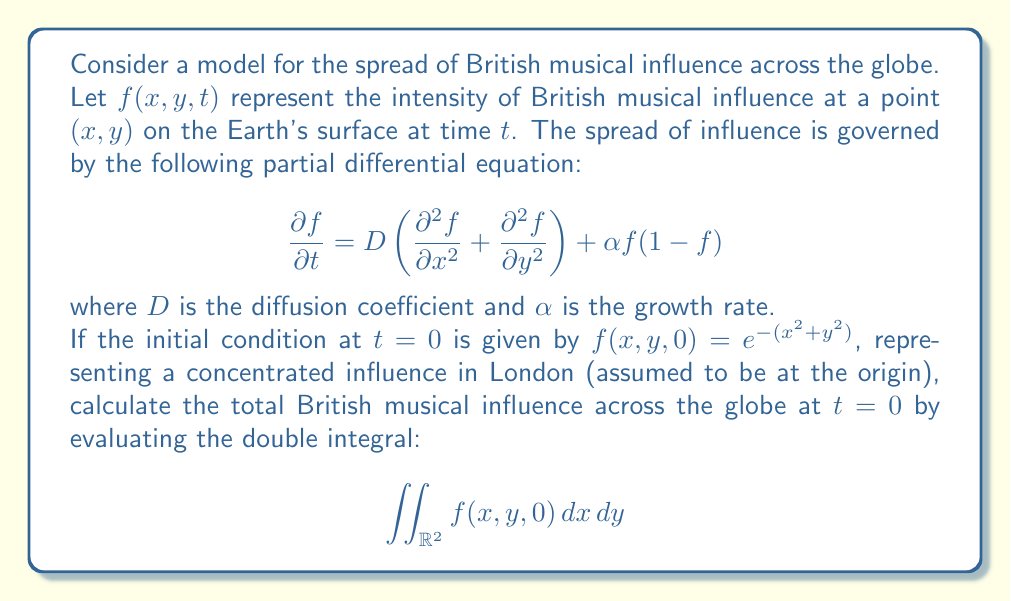What is the answer to this math problem? To solve this problem, we need to follow these steps:

1) First, we identify the initial condition:
   $f(x,y,0) = e^{-(x^2+y^2)}$

2) We need to evaluate the double integral:
   $$\iint_{\mathbb{R}^2} f(x,y,0) \, dx \, dy = \iint_{\mathbb{R}^2} e^{-(x^2+y^2)} \, dx \, dy$$

3) This integral can be solved using polar coordinates. Let's make the substitution:
   $x = r\cos\theta$
   $y = r\sin\theta$
   $dx \, dy = r \, dr \, d\theta$

4) The limits of integration become:
   $0 \leq r < \infty$
   $0 \leq \theta \leq 2\pi$

5) Rewriting the integral:
   $$\int_0^{2\pi} \int_0^{\infty} e^{-r^2} r \, dr \, d\theta$$

6) We can separate this into two integrals:
   $$\int_0^{2\pi} d\theta \cdot \int_0^{\infty} e^{-r^2} r \, dr$$

7) The first integral is simply $2\pi$. For the second integral, we can use the substitution $u = r^2$, $du = 2r \, dr$:
   $$2\pi \cdot \frac{1}{2} \int_0^{\infty} e^{-u} \, du$$

8) The integral $\int_0^{\infty} e^{-u} \, du$ is a well-known result and equals 1.

9) Therefore, the final result is:
   $$2\pi \cdot \frac{1}{2} \cdot 1 = \pi$$
Answer: $\pi$ 